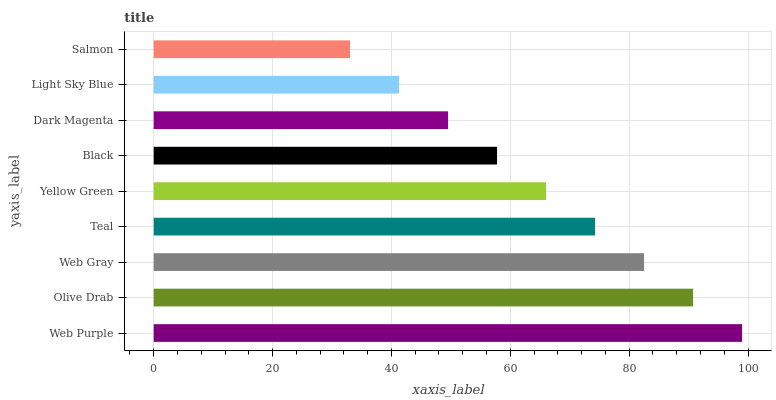Is Salmon the minimum?
Answer yes or no. Yes. Is Web Purple the maximum?
Answer yes or no. Yes. Is Olive Drab the minimum?
Answer yes or no. No. Is Olive Drab the maximum?
Answer yes or no. No. Is Web Purple greater than Olive Drab?
Answer yes or no. Yes. Is Olive Drab less than Web Purple?
Answer yes or no. Yes. Is Olive Drab greater than Web Purple?
Answer yes or no. No. Is Web Purple less than Olive Drab?
Answer yes or no. No. Is Yellow Green the high median?
Answer yes or no. Yes. Is Yellow Green the low median?
Answer yes or no. Yes. Is Teal the high median?
Answer yes or no. No. Is Light Sky Blue the low median?
Answer yes or no. No. 